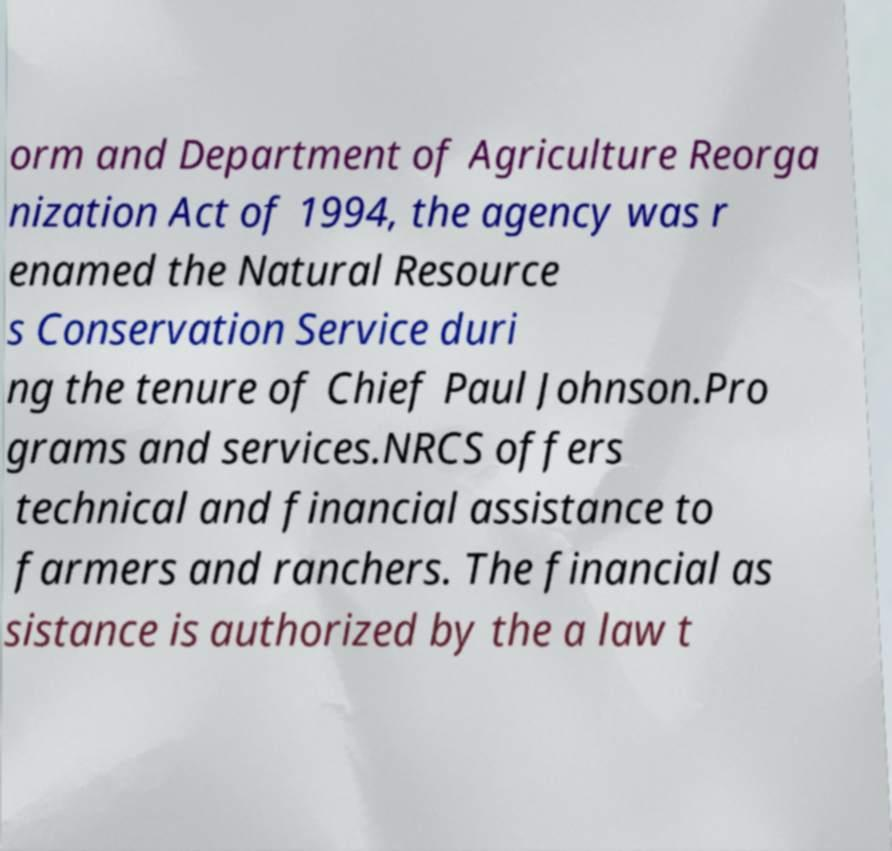Can you read and provide the text displayed in the image?This photo seems to have some interesting text. Can you extract and type it out for me? orm and Department of Agriculture Reorga nization Act of 1994, the agency was r enamed the Natural Resource s Conservation Service duri ng the tenure of Chief Paul Johnson.Pro grams and services.NRCS offers technical and financial assistance to farmers and ranchers. The financial as sistance is authorized by the a law t 